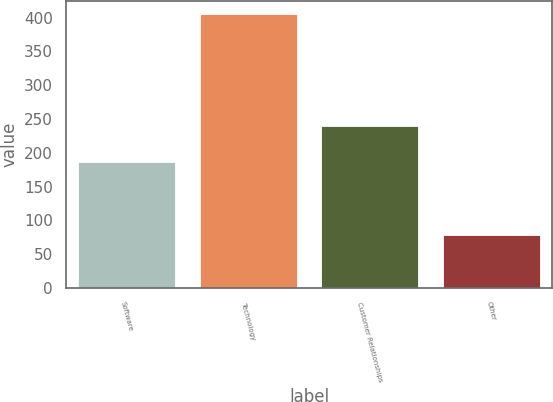Convert chart. <chart><loc_0><loc_0><loc_500><loc_500><bar_chart><fcel>Software<fcel>Technology<fcel>Customer Relationships<fcel>Other<nl><fcel>186<fcel>405<fcel>239<fcel>78<nl></chart> 